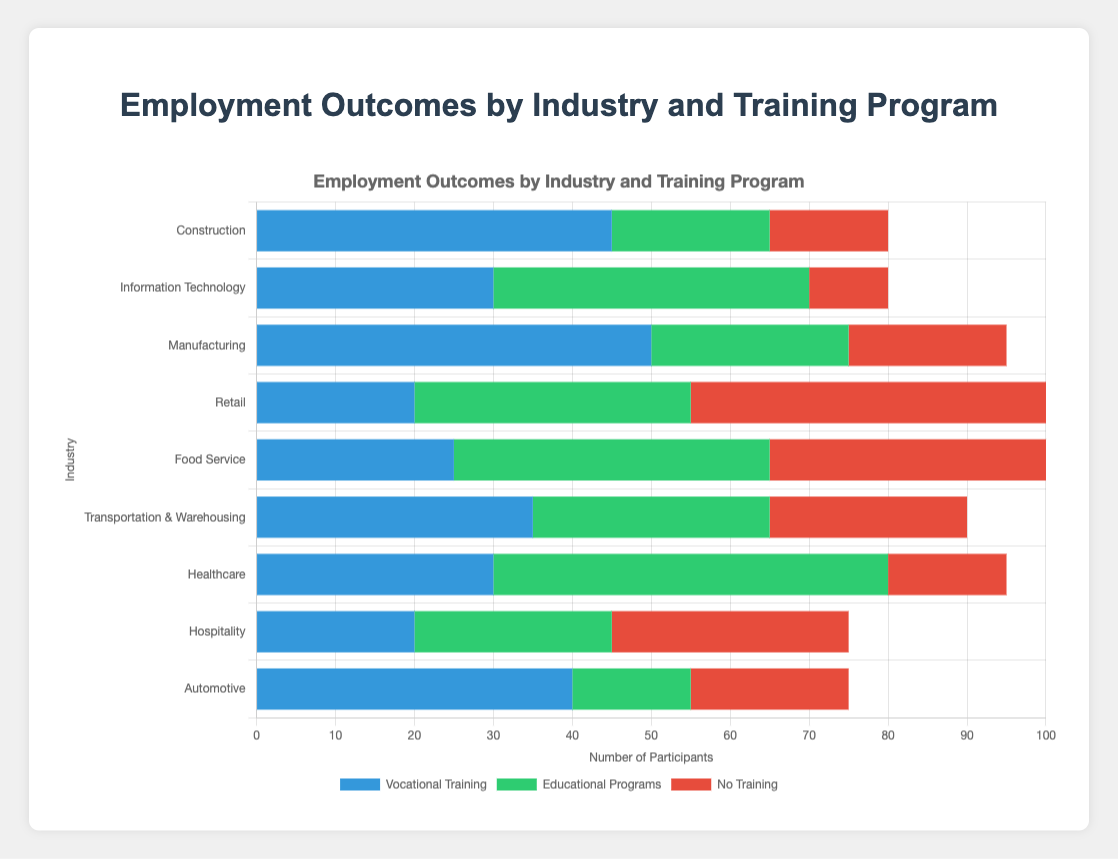Which industry has the highest number of participants with no training? By looking at the horizontal stacked bar chart, observe the lengths of the red sections (no training) for each industry. The industry with the longest red section is Retail.
Answer: Retail Which industry has the most participants in educational programs? By looking at the green sections (educational programs) in the horizontal stacked bar chart, the industry with the longest green section is Healthcare.
Answer: Healthcare What is the total number of participants in the Construction industry? Sum the lengths of the three sections (blue, green, red) for Construction: 45 (vocational) + 20 (educational) + 15 (no training) = 80.
Answer: 80 Between Food Service and Transportation & Warehousing, which industry has more participants with vocational training? Compare the lengths of the blue sections (vocational training) for Food Service and Transportation & Warehousing. Transportation & Warehousing has a longer blue section.
Answer: Transportation & Warehousing What is the difference in the number of participants between educational programs and no training in the IT industry? Subtract the number of participants with no training from those in educational programs for IT: 40 (educational) - 10 (no training) = 30.
Answer: 30 How many total participants are there in the Healthcare and Manufacturing industries combined? Sum the participants across all three training types for Healthcare and Manufacturing: 
Healthcare: 30 (vocational) + 50 (educational) + 15 (no training) = 95 
Manufacturing: 50 (vocational) + 25 (educational) + 20 (no training) = 95 
Total: 95 + 95 = 190.
Answer: 190 Which industry has the smallest number of participants in educational programs? Identify the shortest green section (educational programs); it is in the Automotive industry with 15 participants.
Answer: Automotive 